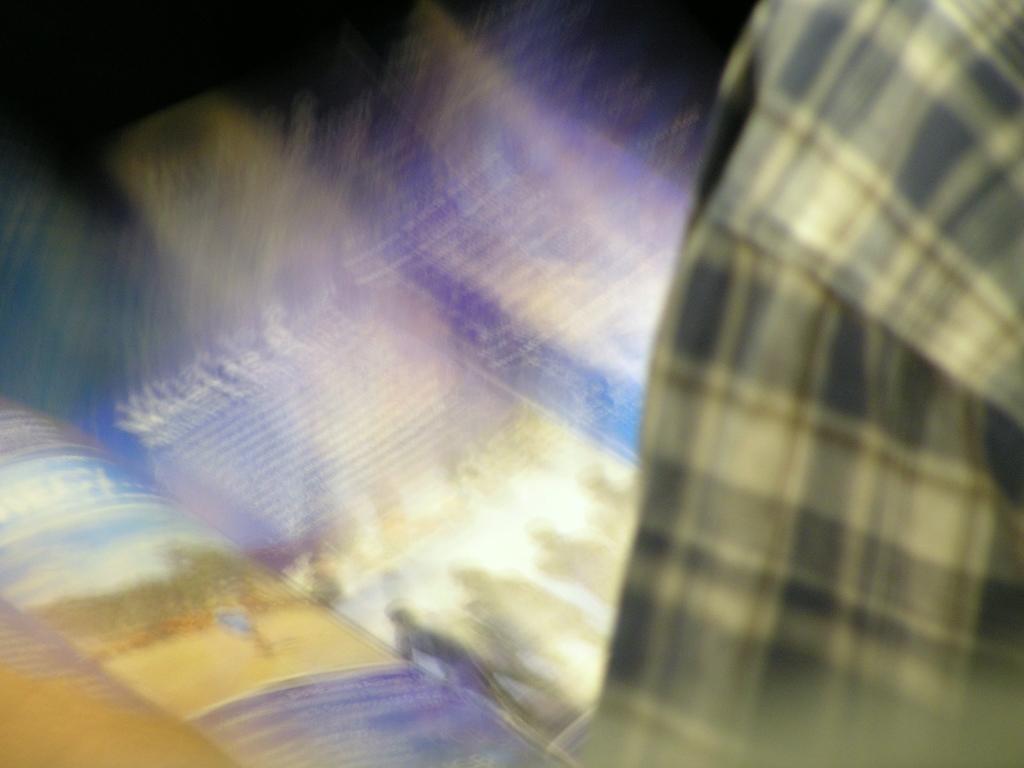Please provide a concise description of this image. In this image, we can see a book and on the right, there is a person's shoulder. 